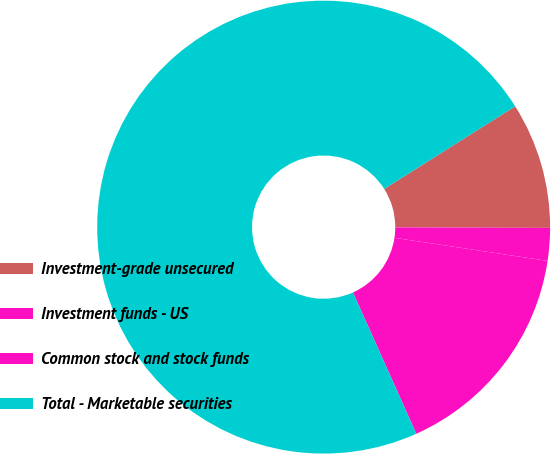Convert chart to OTSL. <chart><loc_0><loc_0><loc_500><loc_500><pie_chart><fcel>Investment-grade unsecured<fcel>Investment funds - US<fcel>Common stock and stock funds<fcel>Total - Marketable securities<nl><fcel>9.01%<fcel>2.33%<fcel>15.91%<fcel>72.75%<nl></chart> 